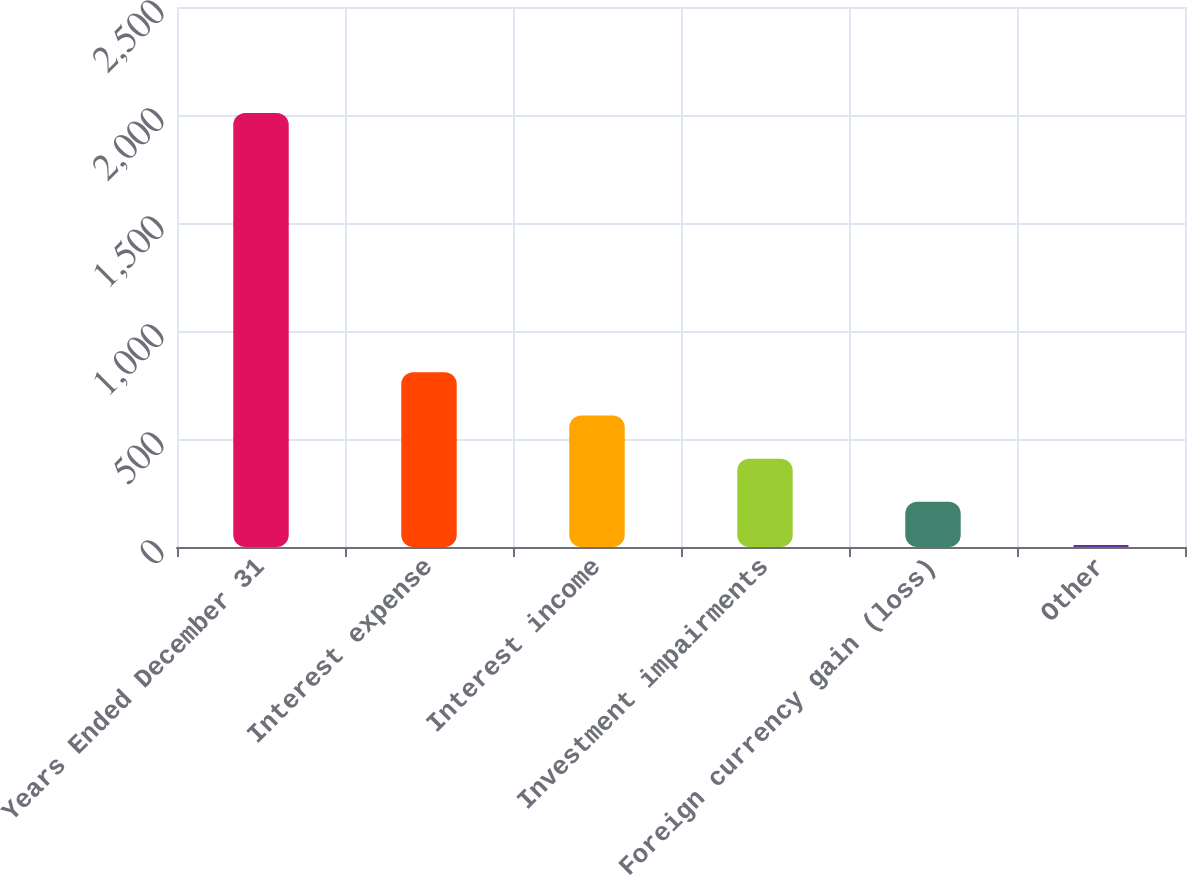<chart> <loc_0><loc_0><loc_500><loc_500><bar_chart><fcel>Years Ended December 31<fcel>Interest expense<fcel>Interest income<fcel>Investment impairments<fcel>Foreign currency gain (loss)<fcel>Other<nl><fcel>2009<fcel>809<fcel>609<fcel>409<fcel>209<fcel>9<nl></chart> 